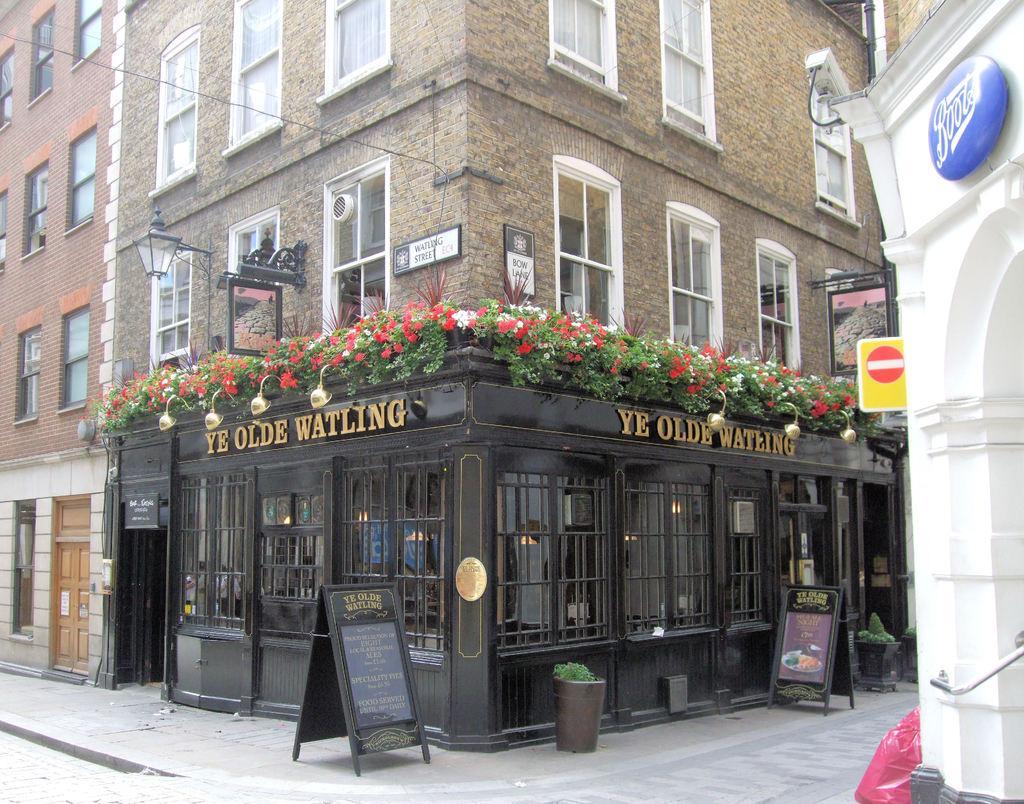Describe this image in one or two sentences. In this image we can see buildings with glass windows. Bottom of the building shop is there. In front of it banners are there. Right side of the image white color wall is present. 